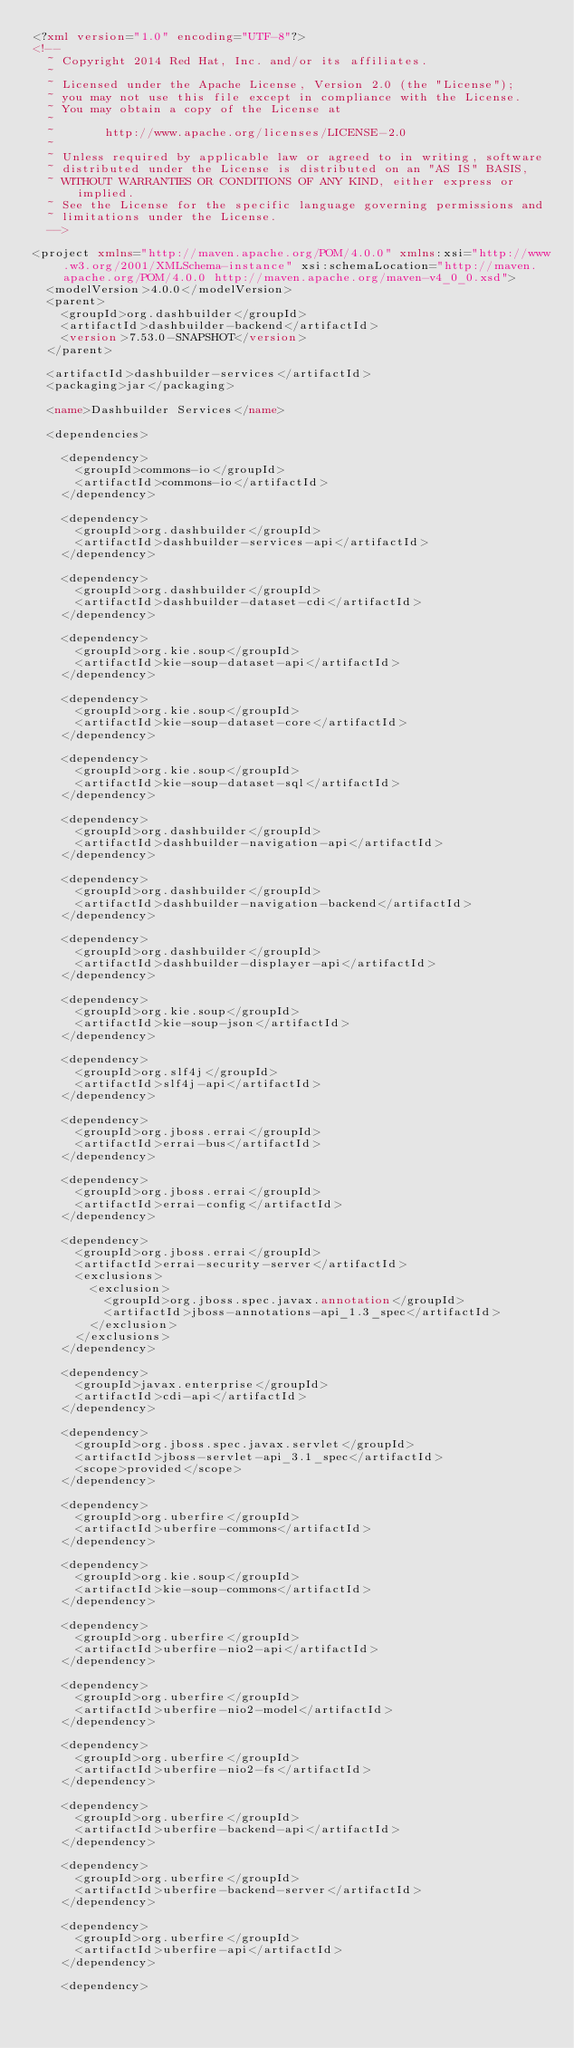<code> <loc_0><loc_0><loc_500><loc_500><_XML_><?xml version="1.0" encoding="UTF-8"?>
<!--
  ~ Copyright 2014 Red Hat, Inc. and/or its affiliates.
  ~
  ~ Licensed under the Apache License, Version 2.0 (the "License");
  ~ you may not use this file except in compliance with the License.
  ~ You may obtain a copy of the License at
  ~
  ~       http://www.apache.org/licenses/LICENSE-2.0
  ~
  ~ Unless required by applicable law or agreed to in writing, software
  ~ distributed under the License is distributed on an "AS IS" BASIS,
  ~ WITHOUT WARRANTIES OR CONDITIONS OF ANY KIND, either express or implied.
  ~ See the License for the specific language governing permissions and
  ~ limitations under the License.
  -->

<project xmlns="http://maven.apache.org/POM/4.0.0" xmlns:xsi="http://www.w3.org/2001/XMLSchema-instance" xsi:schemaLocation="http://maven.apache.org/POM/4.0.0 http://maven.apache.org/maven-v4_0_0.xsd">
  <modelVersion>4.0.0</modelVersion>
  <parent>
    <groupId>org.dashbuilder</groupId>
    <artifactId>dashbuilder-backend</artifactId>
    <version>7.53.0-SNAPSHOT</version>
  </parent>

  <artifactId>dashbuilder-services</artifactId>
  <packaging>jar</packaging>

  <name>Dashbuilder Services</name>

  <dependencies>

    <dependency>
      <groupId>commons-io</groupId>
      <artifactId>commons-io</artifactId>
    </dependency>

    <dependency>
      <groupId>org.dashbuilder</groupId>
      <artifactId>dashbuilder-services-api</artifactId>
    </dependency>

    <dependency>
      <groupId>org.dashbuilder</groupId>
      <artifactId>dashbuilder-dataset-cdi</artifactId>
    </dependency>

    <dependency>
      <groupId>org.kie.soup</groupId>
      <artifactId>kie-soup-dataset-api</artifactId>
    </dependency>

    <dependency>
      <groupId>org.kie.soup</groupId>
      <artifactId>kie-soup-dataset-core</artifactId>
    </dependency>

    <dependency>
      <groupId>org.kie.soup</groupId>
      <artifactId>kie-soup-dataset-sql</artifactId>
    </dependency>

    <dependency>
      <groupId>org.dashbuilder</groupId>
      <artifactId>dashbuilder-navigation-api</artifactId>
    </dependency>

    <dependency>
      <groupId>org.dashbuilder</groupId>
      <artifactId>dashbuilder-navigation-backend</artifactId>
    </dependency>

    <dependency>
      <groupId>org.dashbuilder</groupId>
      <artifactId>dashbuilder-displayer-api</artifactId>
    </dependency>

    <dependency>
      <groupId>org.kie.soup</groupId>
      <artifactId>kie-soup-json</artifactId>
    </dependency>

    <dependency>
      <groupId>org.slf4j</groupId>
      <artifactId>slf4j-api</artifactId>
    </dependency>

    <dependency>
      <groupId>org.jboss.errai</groupId>
      <artifactId>errai-bus</artifactId>
    </dependency>

    <dependency>
      <groupId>org.jboss.errai</groupId>
      <artifactId>errai-config</artifactId>
    </dependency>

    <dependency>
      <groupId>org.jboss.errai</groupId>
      <artifactId>errai-security-server</artifactId>
      <exclusions>
        <exclusion>
          <groupId>org.jboss.spec.javax.annotation</groupId>
          <artifactId>jboss-annotations-api_1.3_spec</artifactId>
        </exclusion>
      </exclusions>
    </dependency>

    <dependency>
      <groupId>javax.enterprise</groupId>
      <artifactId>cdi-api</artifactId>
    </dependency>

    <dependency>
      <groupId>org.jboss.spec.javax.servlet</groupId>
      <artifactId>jboss-servlet-api_3.1_spec</artifactId>
      <scope>provided</scope>
    </dependency>

    <dependency>
      <groupId>org.uberfire</groupId>
      <artifactId>uberfire-commons</artifactId>
    </dependency>

    <dependency>
      <groupId>org.kie.soup</groupId>
      <artifactId>kie-soup-commons</artifactId>
    </dependency>

    <dependency>
      <groupId>org.uberfire</groupId>
      <artifactId>uberfire-nio2-api</artifactId>
    </dependency>

    <dependency>
      <groupId>org.uberfire</groupId>
      <artifactId>uberfire-nio2-model</artifactId>
    </dependency>

    <dependency>
      <groupId>org.uberfire</groupId>
      <artifactId>uberfire-nio2-fs</artifactId>
    </dependency>

    <dependency>
      <groupId>org.uberfire</groupId>
      <artifactId>uberfire-backend-api</artifactId>
    </dependency>

    <dependency>
      <groupId>org.uberfire</groupId>
      <artifactId>uberfire-backend-server</artifactId>
    </dependency>

    <dependency>
      <groupId>org.uberfire</groupId>
      <artifactId>uberfire-api</artifactId>
    </dependency>

    <dependency></code> 